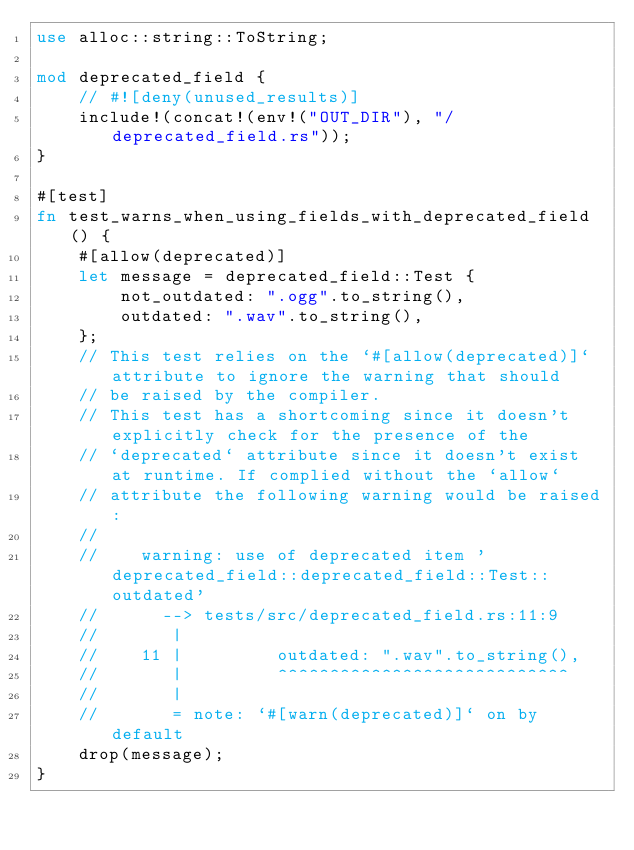<code> <loc_0><loc_0><loc_500><loc_500><_Rust_>use alloc::string::ToString;

mod deprecated_field {
    // #![deny(unused_results)]
    include!(concat!(env!("OUT_DIR"), "/deprecated_field.rs"));
}

#[test]
fn test_warns_when_using_fields_with_deprecated_field() {
    #[allow(deprecated)]
    let message = deprecated_field::Test {
        not_outdated: ".ogg".to_string(),
        outdated: ".wav".to_string(),
    };
    // This test relies on the `#[allow(deprecated)]` attribute to ignore the warning that should
    // be raised by the compiler.
    // This test has a shortcoming since it doesn't explicitly check for the presence of the
    // `deprecated` attribute since it doesn't exist at runtime. If complied without the `allow`
    // attribute the following warning would be raised:
    //
    //    warning: use of deprecated item 'deprecated_field::deprecated_field::Test::outdated'
    //      --> tests/src/deprecated_field.rs:11:9
    //       |
    //    11 |         outdated: ".wav".to_string(),
    //       |         ^^^^^^^^^^^^^^^^^^^^^^^^^^^^
    //       |
    //       = note: `#[warn(deprecated)]` on by default
    drop(message);
}
</code> 